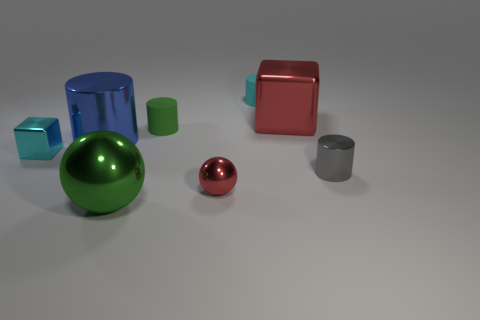Add 1 tiny gray shiny cylinders. How many objects exist? 9 Subtract 0 yellow cylinders. How many objects are left? 8 Subtract all spheres. How many objects are left? 6 Subtract all big green rubber cylinders. Subtract all tiny rubber things. How many objects are left? 6 Add 6 tiny red shiny spheres. How many tiny red shiny spheres are left? 7 Add 7 small cyan objects. How many small cyan objects exist? 9 